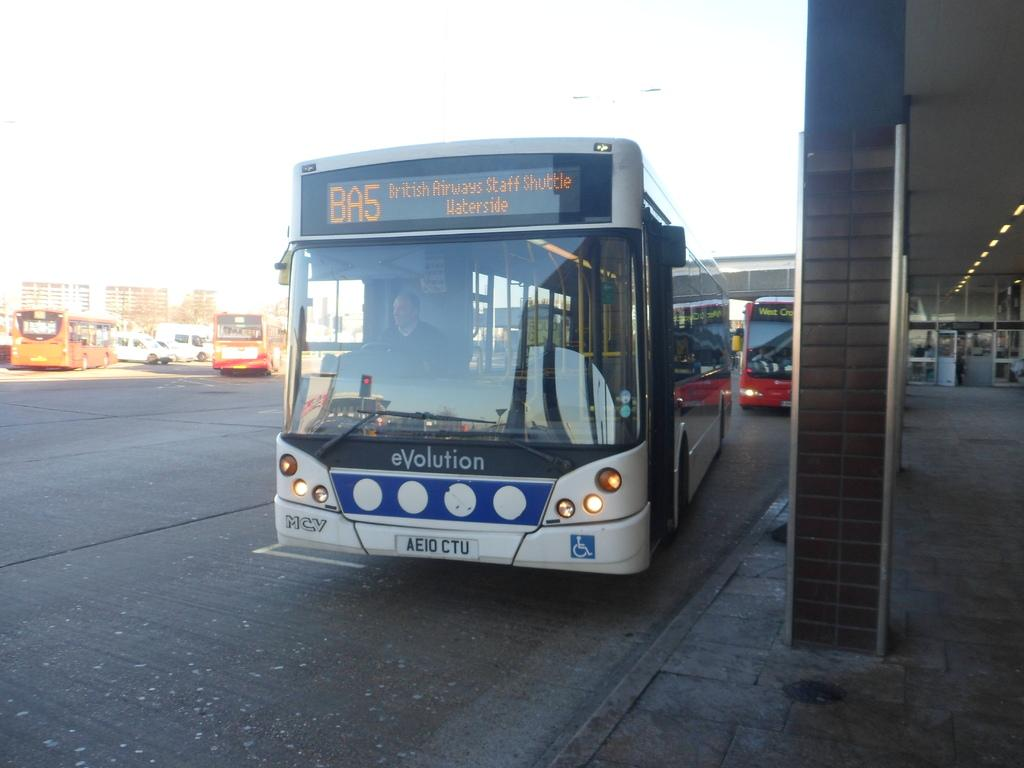What can be seen on the road in the image? There are vehicles on the road in the image. What type of structures can be seen in the image? There are buildings visible in the image. What is present on the roofs of the buildings in the image? There are light arrangements on the roofs in the image. What type of army is marching down the street in the image? There is no army present in the image; it features vehicles on the road and buildings with light arrangements on their roofs. How does the person in the image walk to their destination? There is no person walking in the image; it only shows vehicles on the road, buildings, and light arrangements on the roofs. 